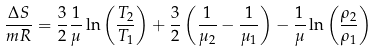<formula> <loc_0><loc_0><loc_500><loc_500>\frac { \Delta S } { m R } = \frac { 3 } { 2 } \frac { 1 } { \mu } \ln \left ( \frac { T _ { 2 } } { T _ { 1 } } \right ) + \frac { 3 } { 2 } \left ( \frac { 1 } { \mu _ { 2 } } - \frac { 1 } { \mu _ { 1 } } \right ) - \frac { 1 } { \mu } \ln \left ( \frac { \rho _ { 2 } } { \rho _ { 1 } } \right )</formula> 